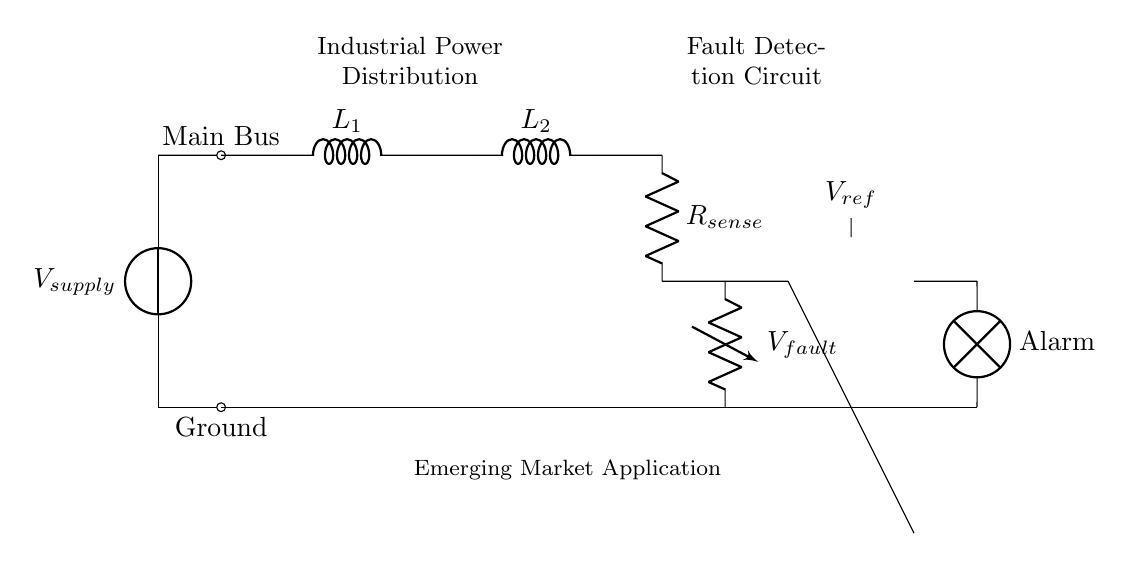What is the main component supplying power to the circuit? The main component is the voltage source labeled V_supply, indicating it provides the necessary power for the circuit operations.
Answer: V_supply What are the two types of inductors present in the circuit? The circuit includes two inductors labeled L_1 and L_2, which are components key to the power distribution process within the system.
Answer: L_1 and L_2 What triggers the alarm in the circuit? The alarm is triggered when the output from the op-amp comparator surpasses the reference voltage V_ref, indicating a fault condition.
Answer: Alarm How many resistors are used in the fault detection circuit? There is one resistor denoted as R_sense, which is responsible for sensing the current that indicates a fault condition in the system.
Answer: 1 What is the purpose of the reference voltage in this circuit? The reference voltage V_ref serves as a threshold for the comparator, which differentiates between normal operating conditions and fault conditions by comparing it to the sensed voltage from the fault detector.
Answer: Threshold Which part of the circuit is responsible for measuring the fault voltage? The resistor R_sense is responsible for measuring the fault voltage; it connects to the fault detection circuit to identify any anomalies in the voltage across it.
Answer: R_sense 